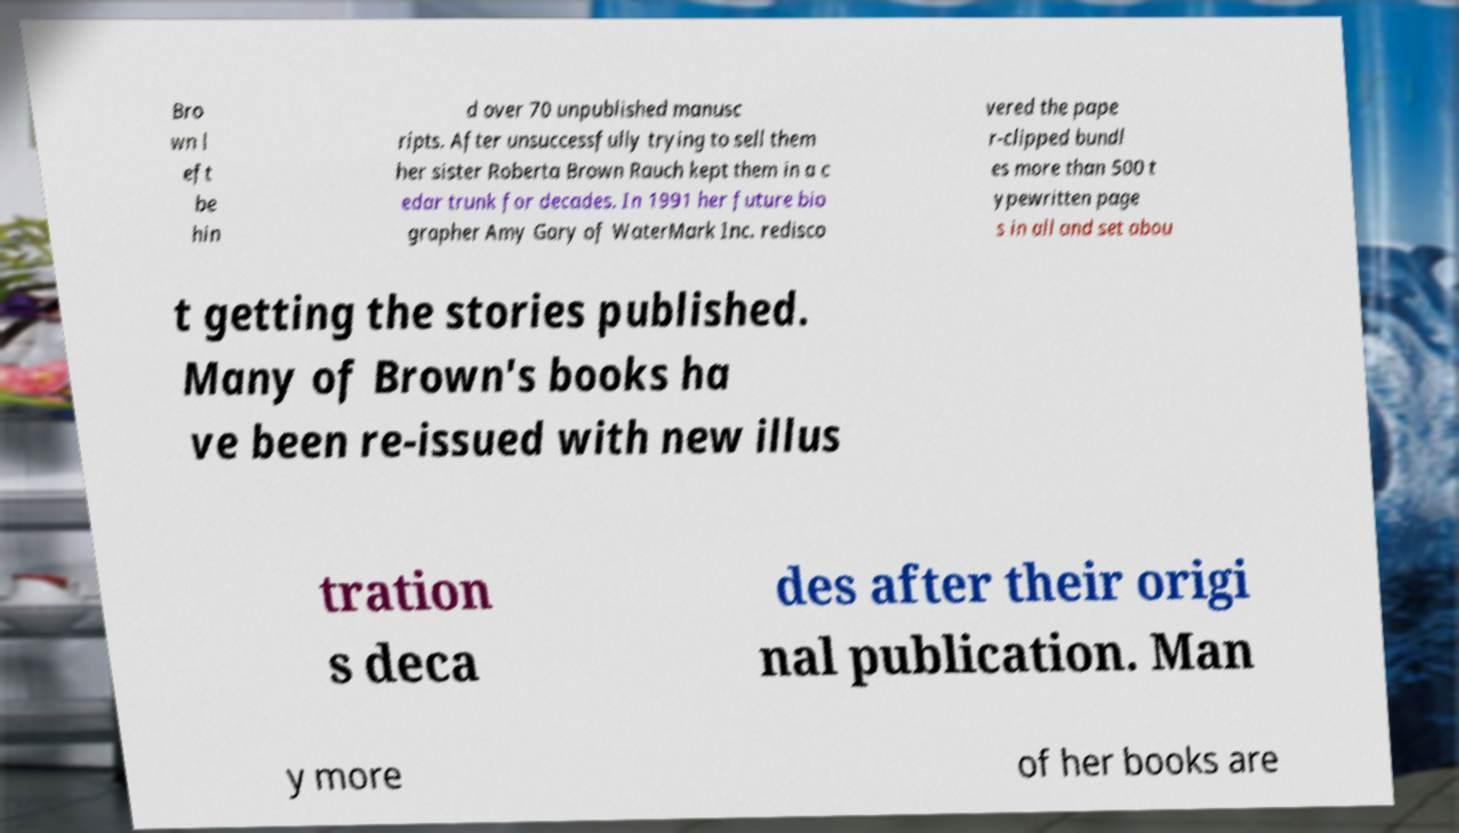Please identify and transcribe the text found in this image. Bro wn l eft be hin d over 70 unpublished manusc ripts. After unsuccessfully trying to sell them her sister Roberta Brown Rauch kept them in a c edar trunk for decades. In 1991 her future bio grapher Amy Gary of WaterMark Inc. redisco vered the pape r-clipped bundl es more than 500 t ypewritten page s in all and set abou t getting the stories published. Many of Brown's books ha ve been re-issued with new illus tration s deca des after their origi nal publication. Man y more of her books are 